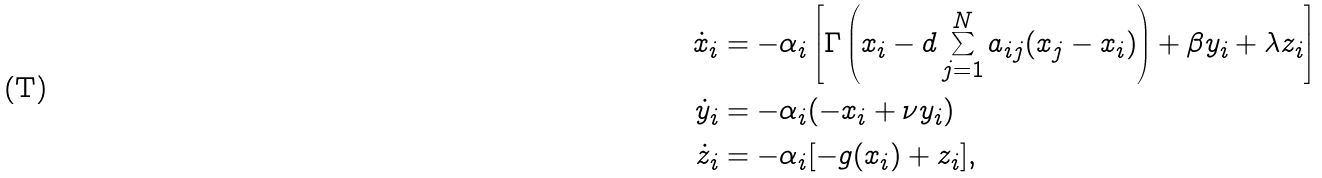Convert formula to latex. <formula><loc_0><loc_0><loc_500><loc_500>\dot { x } _ { i } & = - \alpha _ { i } \left [ \Gamma \left ( x _ { i } - d \sum _ { j = 1 } ^ { N } a _ { i j } ( x _ { j } - x _ { i } ) \right ) + \beta y _ { i } + \lambda z _ { i } \right ] \\ \dot { y } _ { i } & = - \alpha _ { i } ( - x _ { i } + \nu y _ { i } ) \\ \dot { z } _ { i } & = - \alpha _ { i } [ - g ( x _ { i } ) + z _ { i } ] ,</formula> 